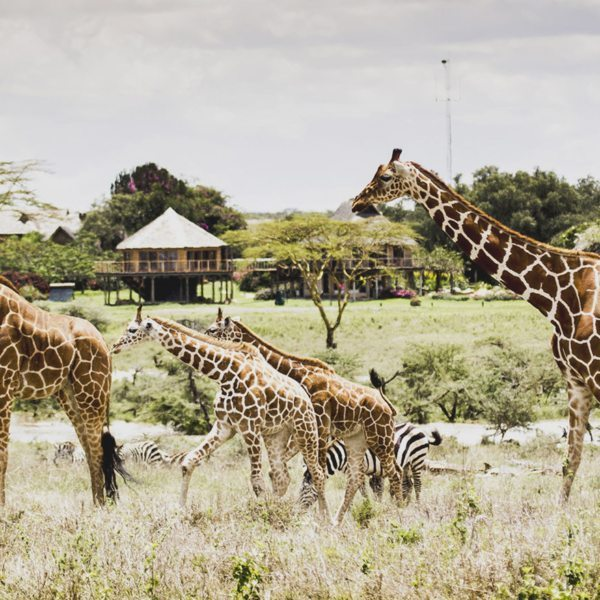This image showcases a savanna with some specific structures. What wildlife might we expect to see around here? The savanna, with its defining sparse trees and open spaces, is home to a diverse array of wildlife. You can expect to see various herbivores like giraffes, zebras, and antelopes grazing on the grasslands. Predators such as lions, cheetahs, and hyenas may also be present, stealthily hunting their prey. Additionally, birds like eagles and vultures soar above, while smaller mammals and reptiles like meerkats and snakes inhabit the underbrush. This ecosystem is vibrant and teeming with life, each species playing a crucial role in maintaining the balance of the savanna. 